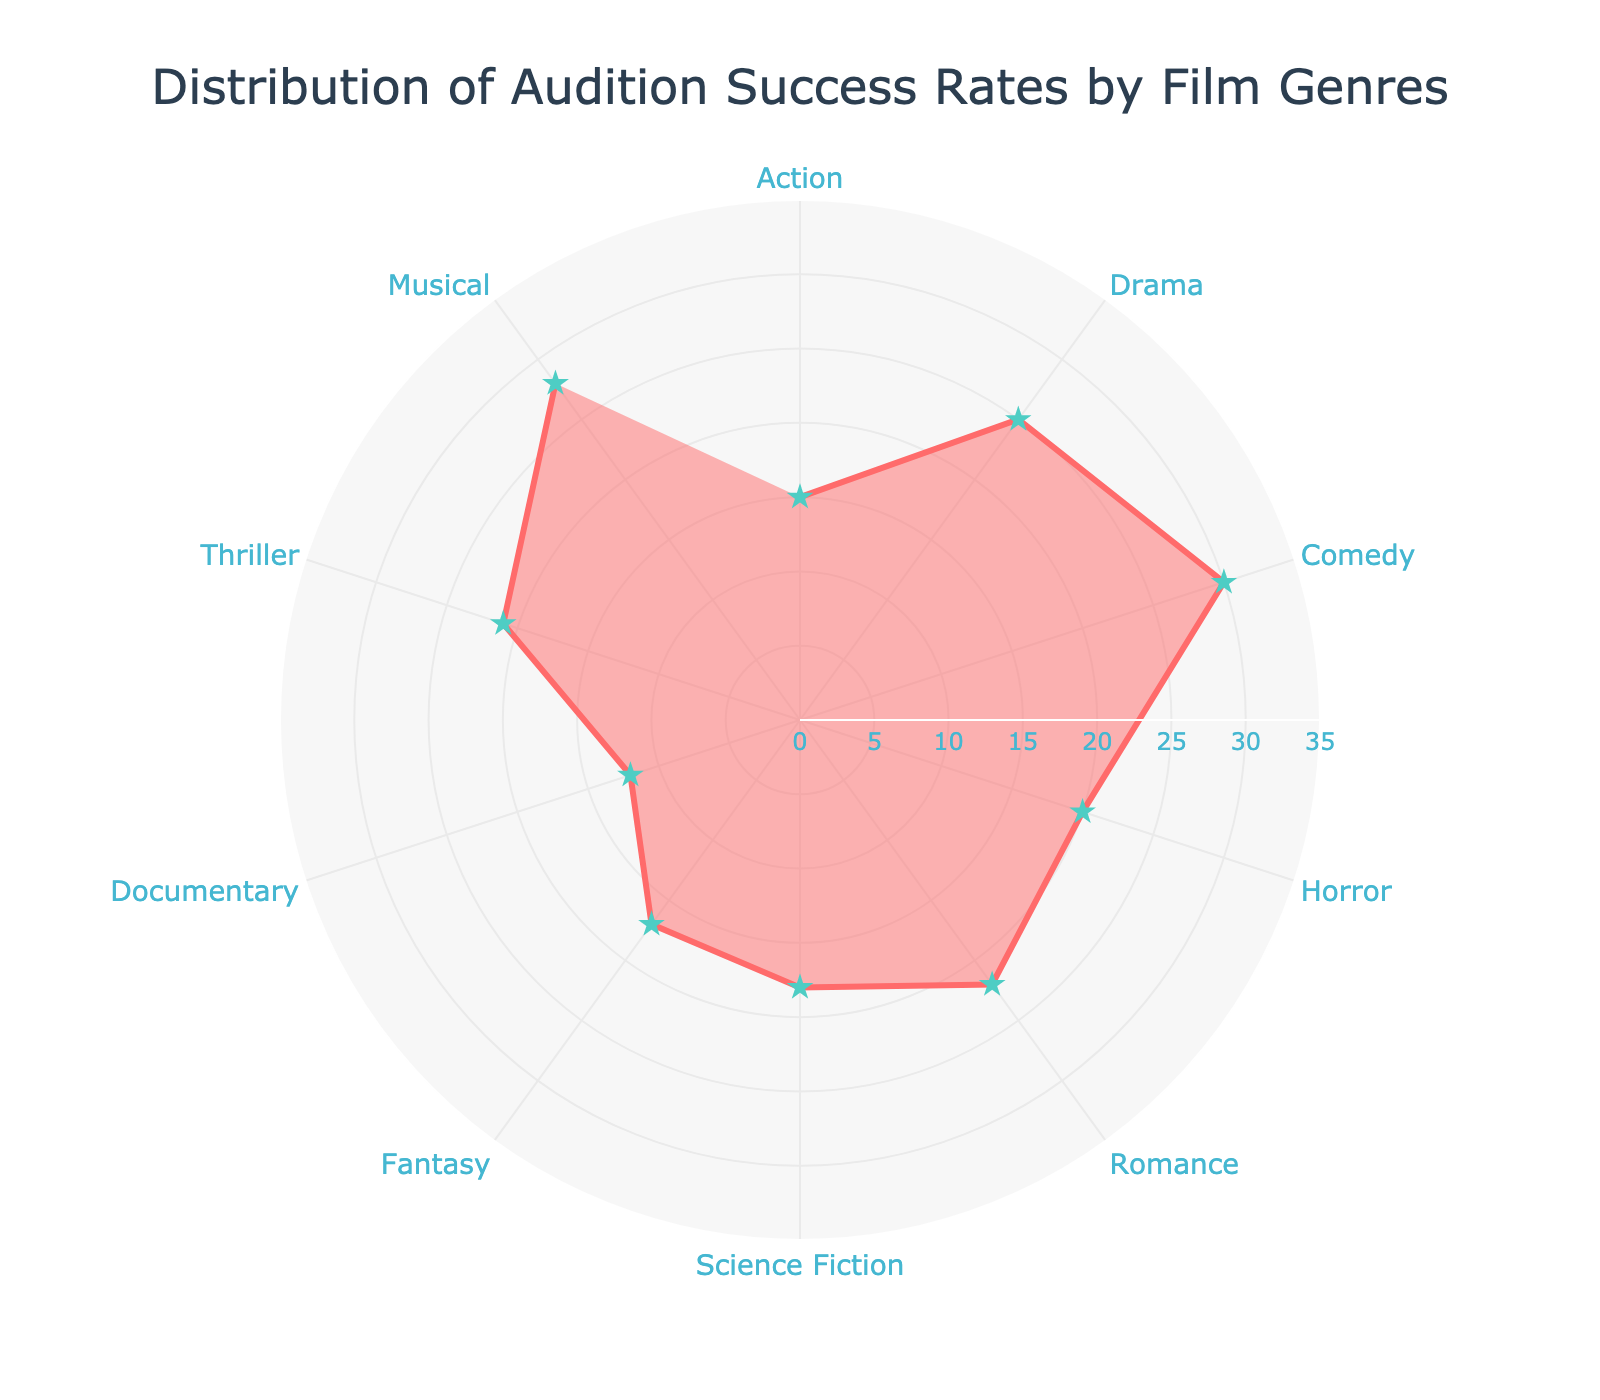What is the title of the figure? The title is usually displayed at the top of the figure, and here it reads "Distribution of Audition Success Rates by Film Genres."
Answer: Distribution of Audition Success Rates by Film Genres What is the highest audition success rate and which genre does it belong to? By looking at the plot, the highest point on the radial axis is at 30, which corresponds to the Comedy genre.
Answer: 30, Comedy What is the success rate for the Documentary genre? Locate the Documentary label on the angular axis and follow the radial line to its endpoint, which shows a success rate of 12.
Answer: 12 Which genre has a success rate higher than Musical but lower than Comedy? Compare the success rates. Comedy has the highest rate of 30, Musical has 28. Find the genre with a success rate between these values, which is Drama with 25.
Answer: Drama What is the success rate difference between Romance and Horror genres? Romance has a success rate of 22 and Horror has a success rate of 20. Subtract the smaller value from the larger: 22 - 20 = 2.
Answer: 2 Which genres have a success rate less than 20? Locate the genres where the values are below the 20 mark. These are Science Fiction (18), Fantasy (17), and Documentary (12).
Answer: Science Fiction, Fantasy, Documentary What is the average success rate of all genres? Sum all the success rates and divide by the number of genres. (15+25+30+20+22+18+17+12+21+28) / 10 = 20.8.
Answer: 20.8 Which two genres have the closest success rates? Look for the smallest difference in success rates. Fantasy (17) and Action (15) have the smallest difference of 2.
Answer: Fantasy and Action What is the median success rate of the genres? Arrange the success rates in ascending order: [12, 15, 17, 18, 20, 21, 22, 25, 28, 30]. The middle values are 20 and 21, the median is (20+21)/2 = 20.5
Answer: 20.5 Describe the visual appearance of the markers on the points. The markers on the points are in the shape of stars and are colored in a light teal shade.
Answer: Star-shaped, light teal 